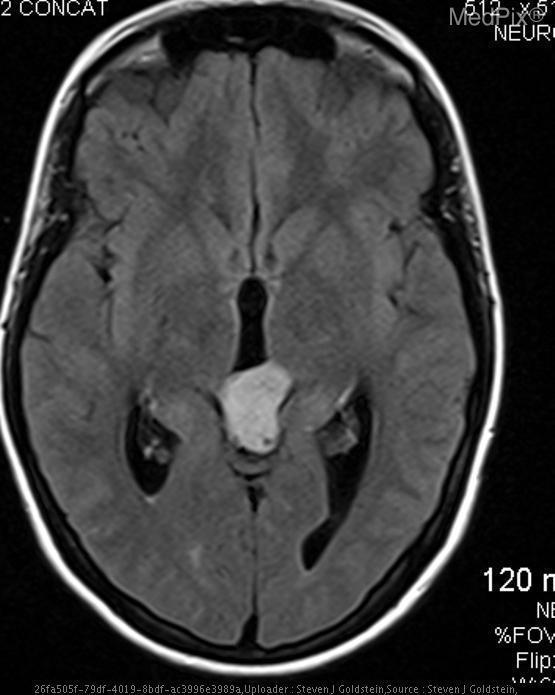Is the mass enhancing?
Be succinct. No. Is there evidence of calcification?
Give a very brief answer. No. Is the mass calcified?
Short answer required. No. What is the location of the mass?
Keep it brief. Pineal gland. Where is the mass located?
Be succinct. Pineal gland. Is there evidence of hemorrhage?
Quick response, please. No. Is the mass hemorrhagic?
Concise answer only. No. 